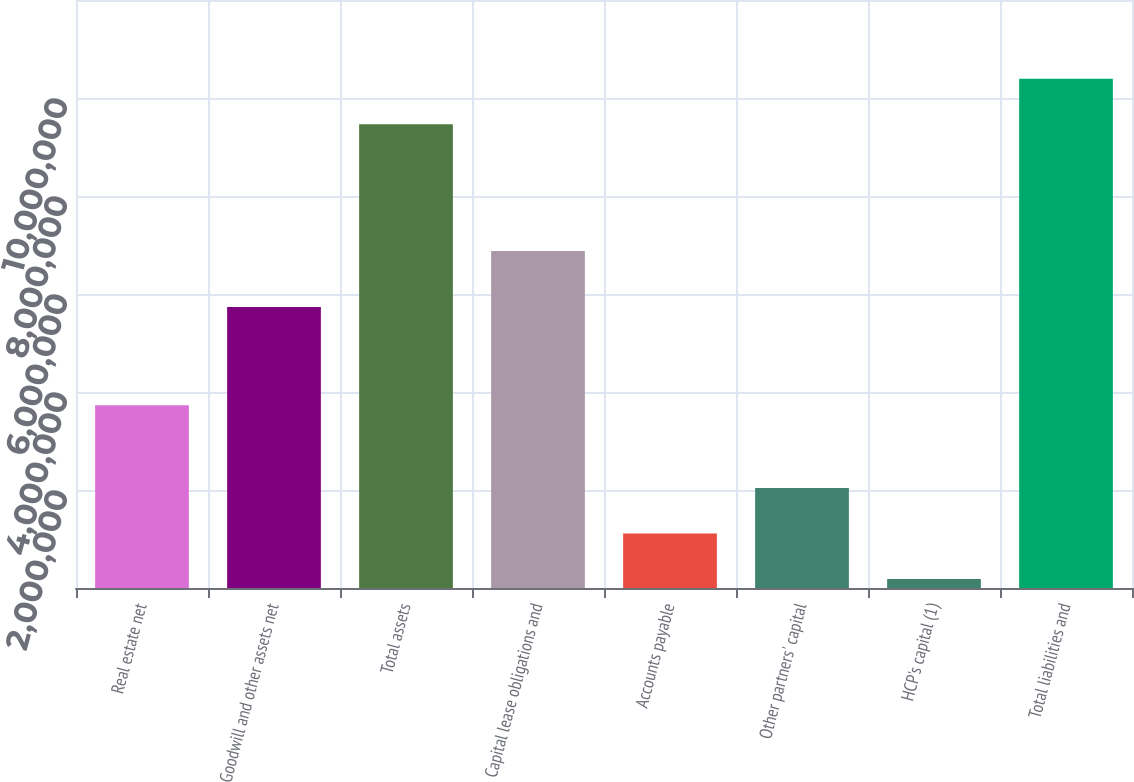Convert chart to OTSL. <chart><loc_0><loc_0><loc_500><loc_500><bar_chart><fcel>Real estate net<fcel>Goodwill and other assets net<fcel>Total assets<fcel>Capital lease obligations and<fcel>Accounts payable<fcel>Other partners' capital<fcel>HCP's capital (1)<fcel>Total liabilities and<nl><fcel>3.73174e+06<fcel>5.73432e+06<fcel>9.46606e+06<fcel>6.87593e+06<fcel>1.11144e+06<fcel>2.03973e+06<fcel>183146<fcel>1.03943e+07<nl></chart> 